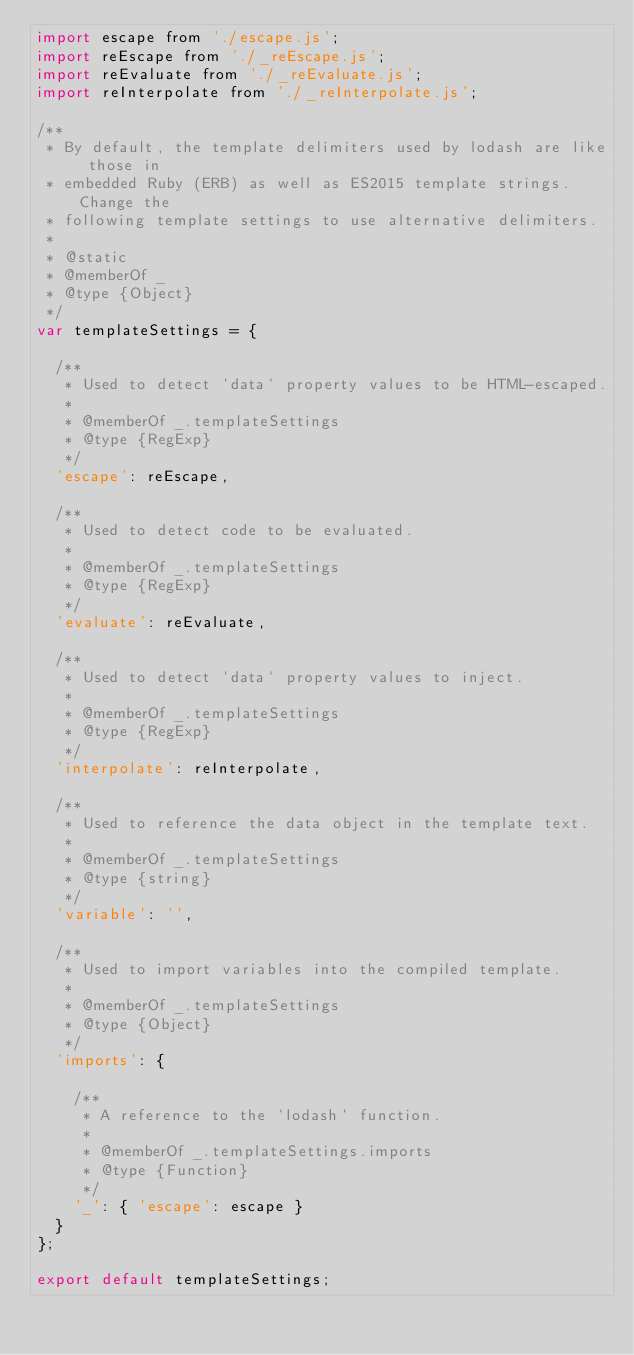<code> <loc_0><loc_0><loc_500><loc_500><_JavaScript_>import escape from './escape.js';
import reEscape from './_reEscape.js';
import reEvaluate from './_reEvaluate.js';
import reInterpolate from './_reInterpolate.js';

/**
 * By default, the template delimiters used by lodash are like those in
 * embedded Ruby (ERB) as well as ES2015 template strings. Change the
 * following template settings to use alternative delimiters.
 *
 * @static
 * @memberOf _
 * @type {Object}
 */
var templateSettings = {

  /**
   * Used to detect `data` property values to be HTML-escaped.
   *
   * @memberOf _.templateSettings
   * @type {RegExp}
   */
  'escape': reEscape,

  /**
   * Used to detect code to be evaluated.
   *
   * @memberOf _.templateSettings
   * @type {RegExp}
   */
  'evaluate': reEvaluate,

  /**
   * Used to detect `data` property values to inject.
   *
   * @memberOf _.templateSettings
   * @type {RegExp}
   */
  'interpolate': reInterpolate,

  /**
   * Used to reference the data object in the template text.
   *
   * @memberOf _.templateSettings
   * @type {string}
   */
  'variable': '',

  /**
   * Used to import variables into the compiled template.
   *
   * @memberOf _.templateSettings
   * @type {Object}
   */
  'imports': {

    /**
     * A reference to the `lodash` function.
     *
     * @memberOf _.templateSettings.imports
     * @type {Function}
     */
    '_': { 'escape': escape }
  }
};

export default templateSettings;
</code> 